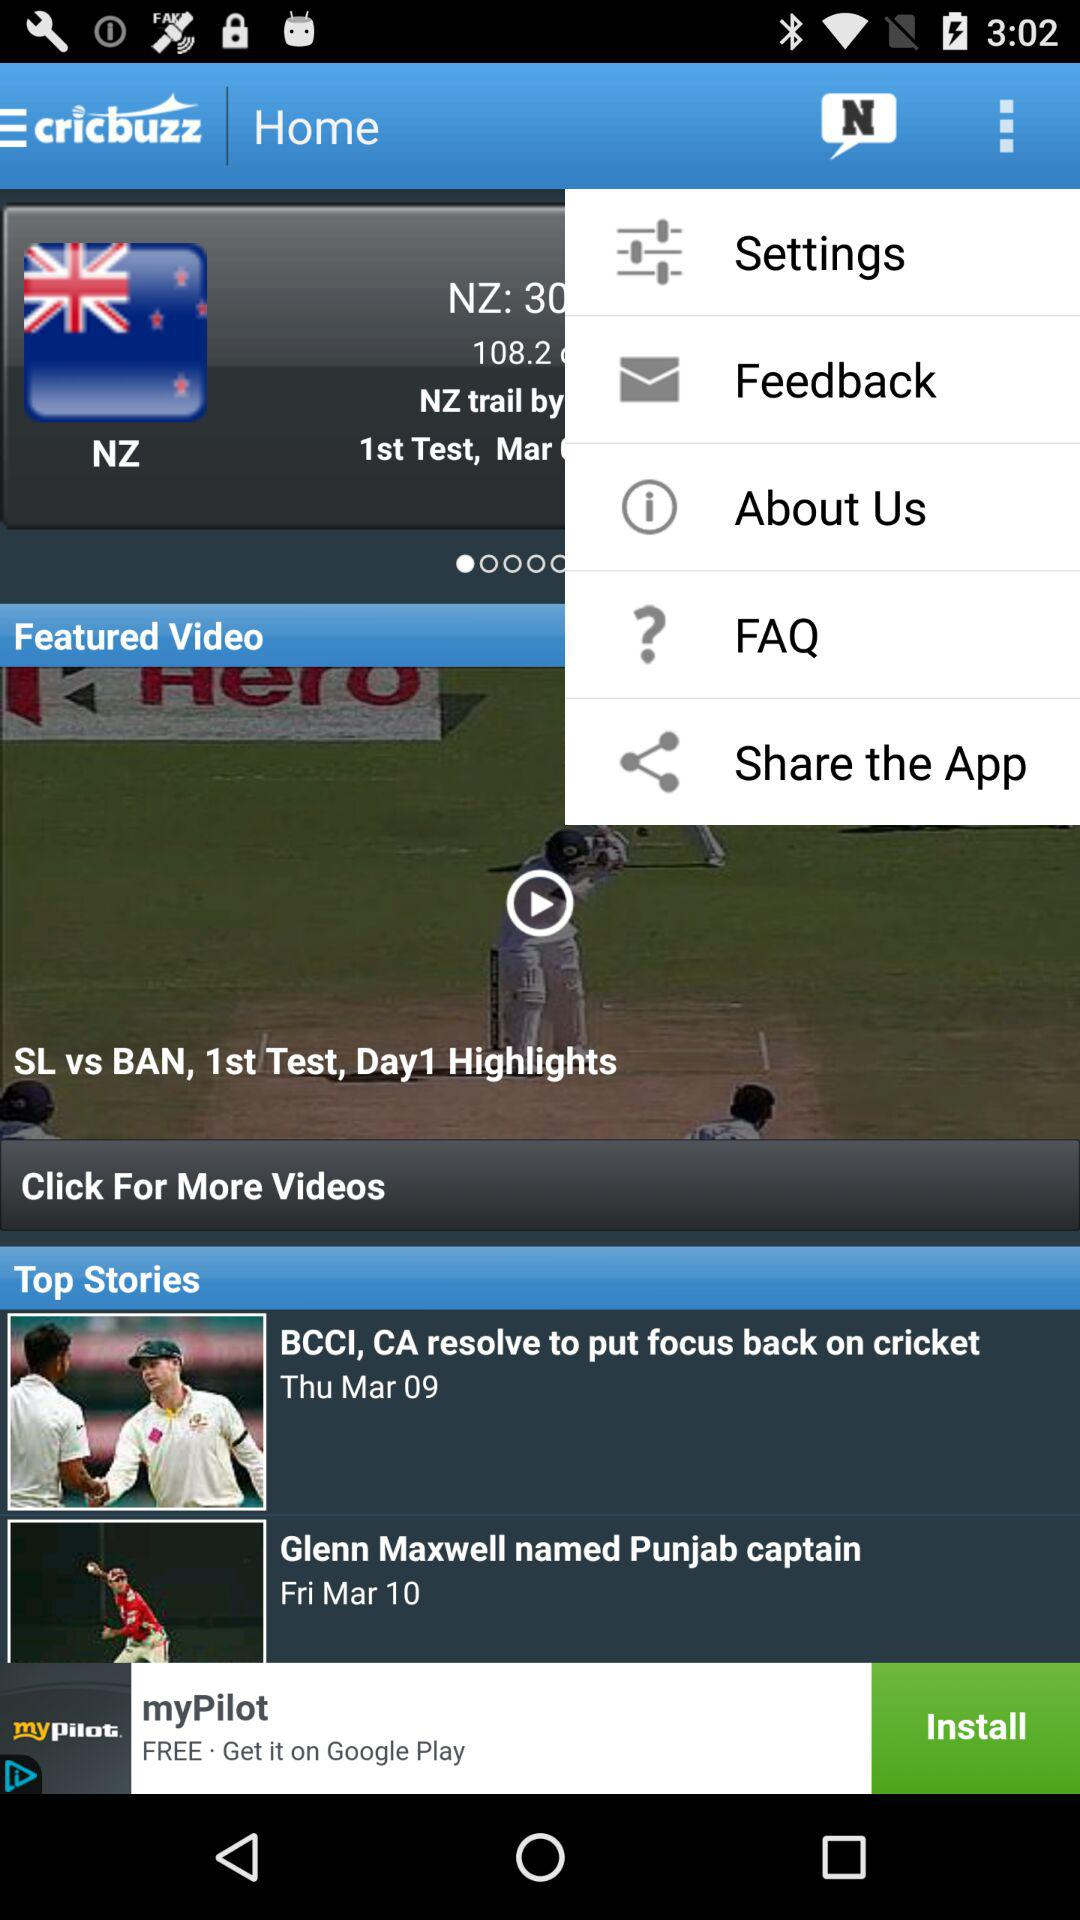What is the application name? The application name is "cricbuzz". 